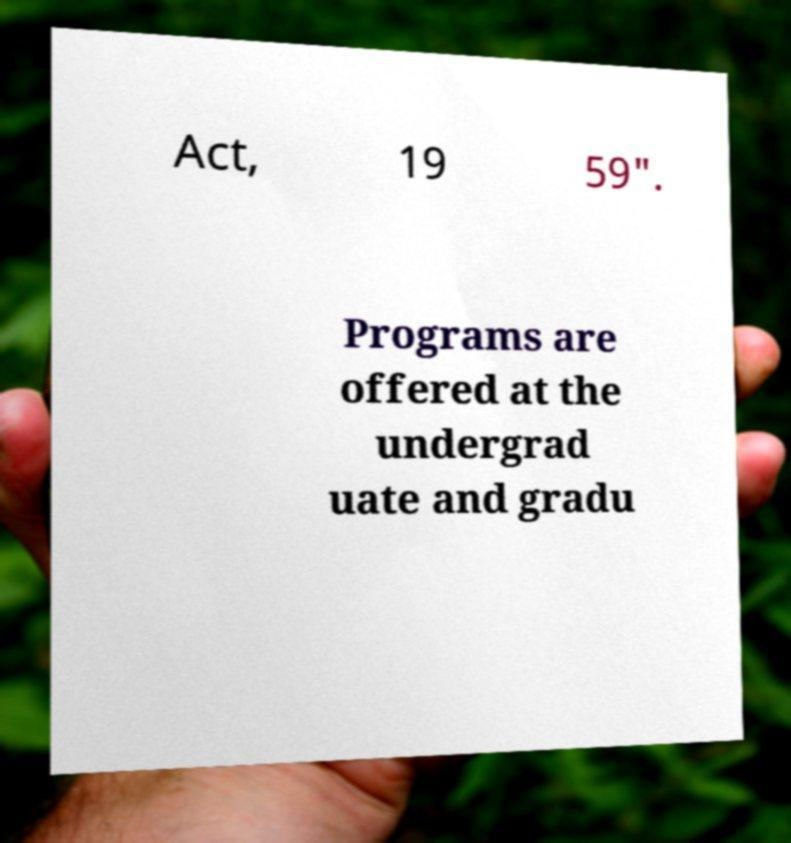I need the written content from this picture converted into text. Can you do that? Act, 19 59". Programs are offered at the undergrad uate and gradu 